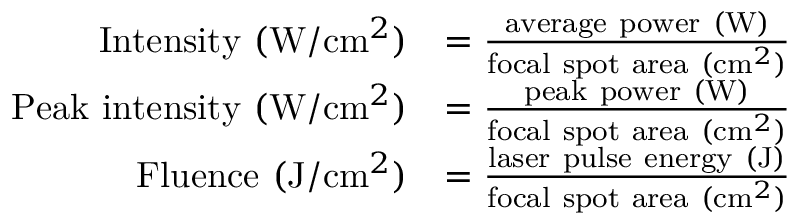<formula> <loc_0><loc_0><loc_500><loc_500>{ \begin{array} { r l } { { I n t e n s i t y } ( W / c m ^ { 2 } ) } & { = { \frac { { a v e r a g e p o w e r } ( W ) } { { f o c a l s p o t a r e a } ( c m ^ { 2 } ) } } } \\ { { P e a k i n t e n s i t y } ( W / c m ^ { 2 } ) } & { = { \frac { { p e a k p o w e r } ( W ) } { { f o c a l s p o t a r e a } ( c m ^ { 2 } ) } } } \\ { { F l u e n c e } ( J / c m ^ { 2 } ) } & { = { \frac { { l a s e r p u l s e e n e r g y } ( J ) } { { f o c a l s p o t a r e a } ( c m ^ { 2 } ) } } } \end{array} }</formula> 